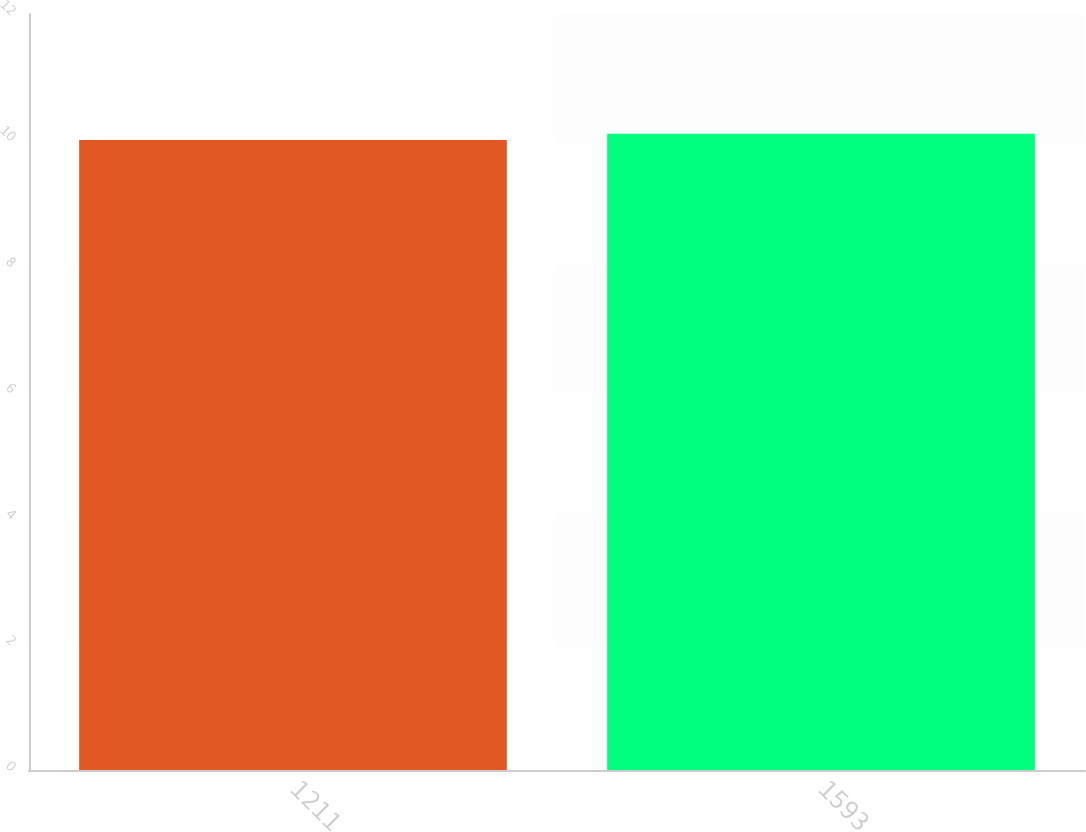<chart> <loc_0><loc_0><loc_500><loc_500><bar_chart><fcel>1211<fcel>1593<nl><fcel>10<fcel>10.1<nl></chart> 